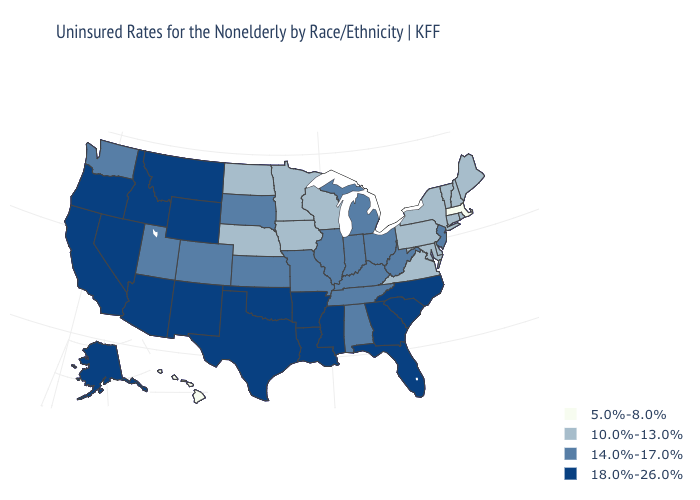Does Rhode Island have a higher value than Hawaii?
Be succinct. Yes. Does Kentucky have the lowest value in the South?
Keep it brief. No. Among the states that border Kansas , which have the lowest value?
Short answer required. Nebraska. Among the states that border Texas , which have the highest value?
Write a very short answer. Arkansas, Louisiana, New Mexico, Oklahoma. Is the legend a continuous bar?
Be succinct. No. What is the highest value in the West ?
Keep it brief. 18.0%-26.0%. What is the highest value in states that border Texas?
Give a very brief answer. 18.0%-26.0%. Among the states that border California , which have the highest value?
Give a very brief answer. Arizona, Nevada, Oregon. Name the states that have a value in the range 18.0%-26.0%?
Short answer required. Alaska, Arizona, Arkansas, California, Florida, Georgia, Idaho, Louisiana, Mississippi, Montana, Nevada, New Mexico, North Carolina, Oklahoma, Oregon, South Carolina, Texas, Wyoming. What is the highest value in the MidWest ?
Keep it brief. 14.0%-17.0%. What is the value of Indiana?
Keep it brief. 14.0%-17.0%. Name the states that have a value in the range 18.0%-26.0%?
Answer briefly. Alaska, Arizona, Arkansas, California, Florida, Georgia, Idaho, Louisiana, Mississippi, Montana, Nevada, New Mexico, North Carolina, Oklahoma, Oregon, South Carolina, Texas, Wyoming. What is the value of Texas?
Give a very brief answer. 18.0%-26.0%. What is the highest value in the West ?
Short answer required. 18.0%-26.0%. Does the map have missing data?
Be succinct. No. 